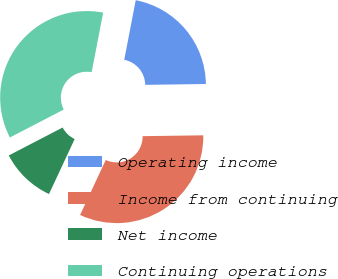Convert chart to OTSL. <chart><loc_0><loc_0><loc_500><loc_500><pie_chart><fcel>Operating income<fcel>Income from continuing<fcel>Net income<fcel>Continuing operations<nl><fcel>21.74%<fcel>32.17%<fcel>10.43%<fcel>35.65%<nl></chart> 